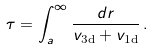Convert formula to latex. <formula><loc_0><loc_0><loc_500><loc_500>\tau = \int _ { a } ^ { \infty } \frac { d r } { v _ { \text {3d} } + v _ { \text {1d} } } \, .</formula> 